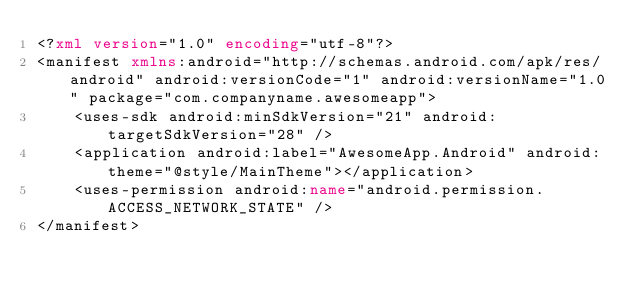Convert code to text. <code><loc_0><loc_0><loc_500><loc_500><_XML_><?xml version="1.0" encoding="utf-8"?>
<manifest xmlns:android="http://schemas.android.com/apk/res/android" android:versionCode="1" android:versionName="1.0" package="com.companyname.awesomeapp">
    <uses-sdk android:minSdkVersion="21" android:targetSdkVersion="28" />
    <application android:label="AwesomeApp.Android" android:theme="@style/MainTheme"></application>
    <uses-permission android:name="android.permission.ACCESS_NETWORK_STATE" />
</manifest>
</code> 